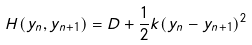<formula> <loc_0><loc_0><loc_500><loc_500>H ( y _ { n } , y _ { n + 1 } ) = D + \frac { 1 } { 2 } k ( y _ { n } - y _ { n + 1 } ) ^ { 2 }</formula> 